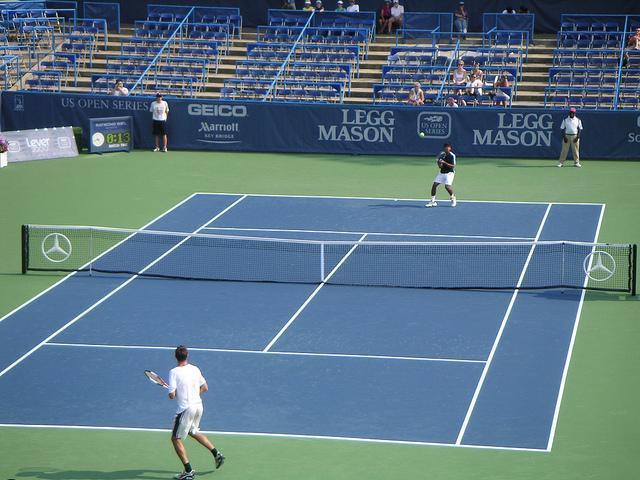How many people are there?
Give a very brief answer. 2. How many bicycles do you see?
Give a very brief answer. 0. 